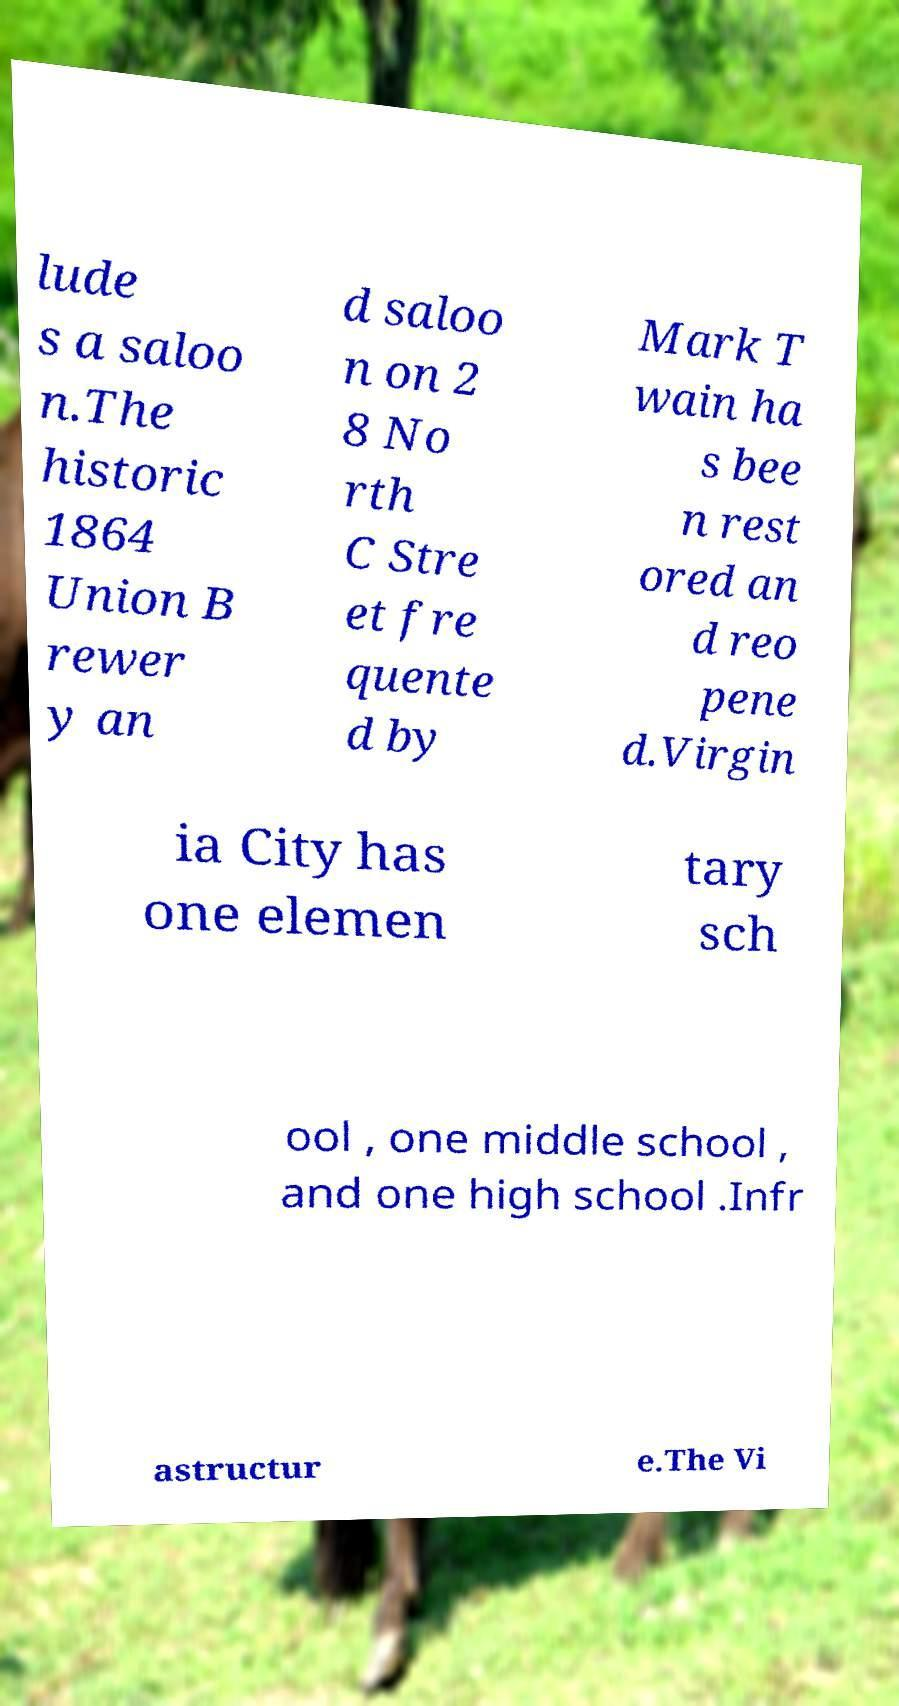Please identify and transcribe the text found in this image. lude s a saloo n.The historic 1864 Union B rewer y an d saloo n on 2 8 No rth C Stre et fre quente d by Mark T wain ha s bee n rest ored an d reo pene d.Virgin ia City has one elemen tary sch ool , one middle school , and one high school .Infr astructur e.The Vi 